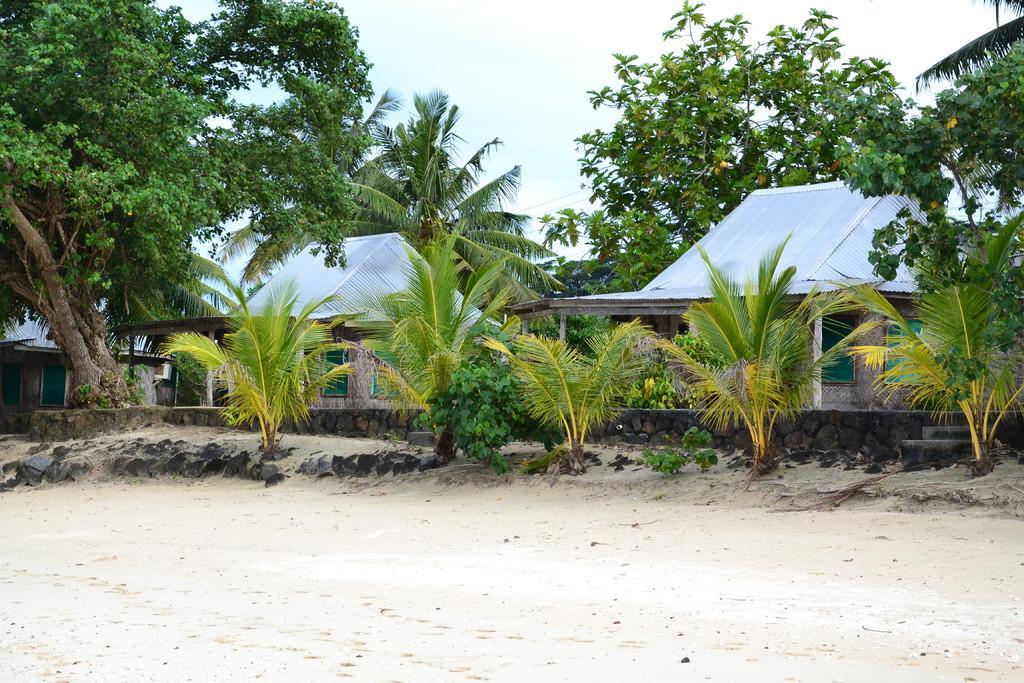Describe this image in one or two sentences. In this picture we can see the sky, shelters, trees, plants. On the ground we can see few stones and the sand. Far we can see the green windows. 